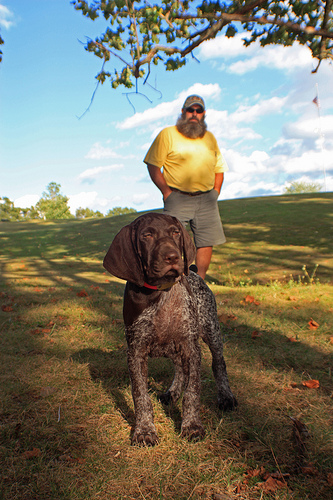Describe the setting and mood depicted in this image. The image captures a serene outdoor setting with a large tree casting shadows and a clear sky above. The mood is peaceful and relaxed, showcasing a man with a dog, enjoying a sunny day outdoors. 